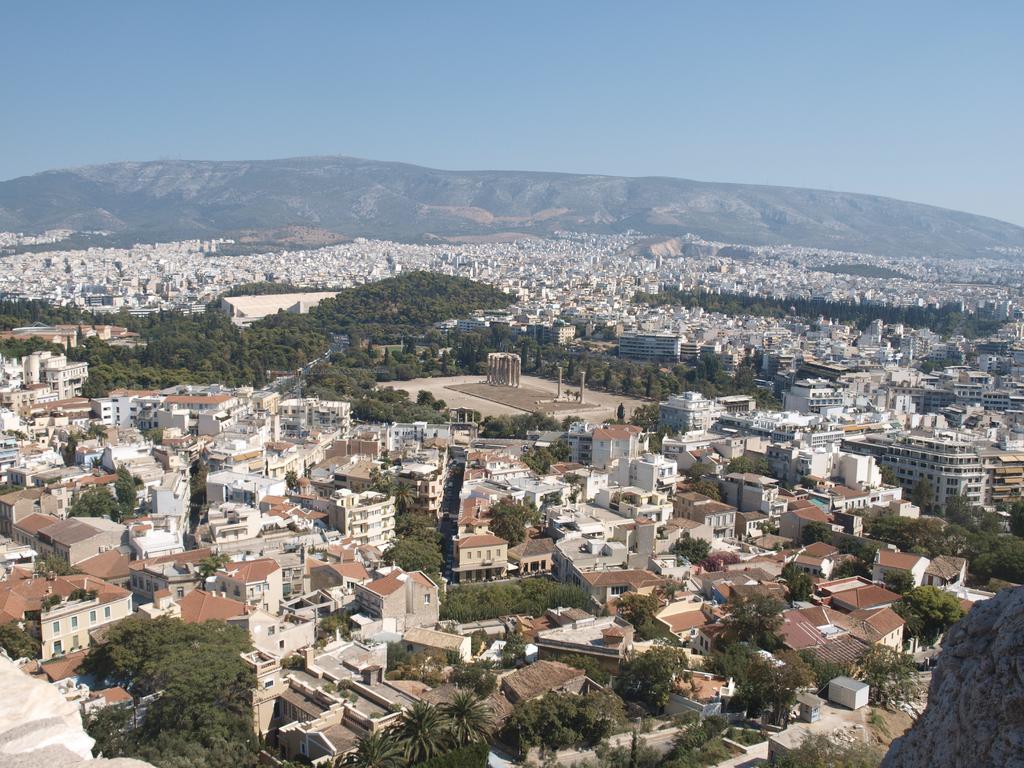Can you describe this image briefly? In the image we can see there is a top view of an area, there are lot of buildings and trees. 